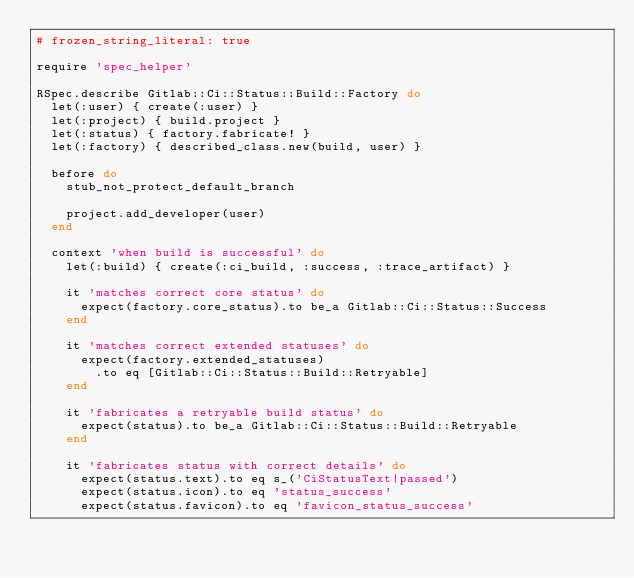<code> <loc_0><loc_0><loc_500><loc_500><_Ruby_># frozen_string_literal: true

require 'spec_helper'

RSpec.describe Gitlab::Ci::Status::Build::Factory do
  let(:user) { create(:user) }
  let(:project) { build.project }
  let(:status) { factory.fabricate! }
  let(:factory) { described_class.new(build, user) }

  before do
    stub_not_protect_default_branch

    project.add_developer(user)
  end

  context 'when build is successful' do
    let(:build) { create(:ci_build, :success, :trace_artifact) }

    it 'matches correct core status' do
      expect(factory.core_status).to be_a Gitlab::Ci::Status::Success
    end

    it 'matches correct extended statuses' do
      expect(factory.extended_statuses)
        .to eq [Gitlab::Ci::Status::Build::Retryable]
    end

    it 'fabricates a retryable build status' do
      expect(status).to be_a Gitlab::Ci::Status::Build::Retryable
    end

    it 'fabricates status with correct details' do
      expect(status.text).to eq s_('CiStatusText|passed')
      expect(status.icon).to eq 'status_success'
      expect(status.favicon).to eq 'favicon_status_success'</code> 